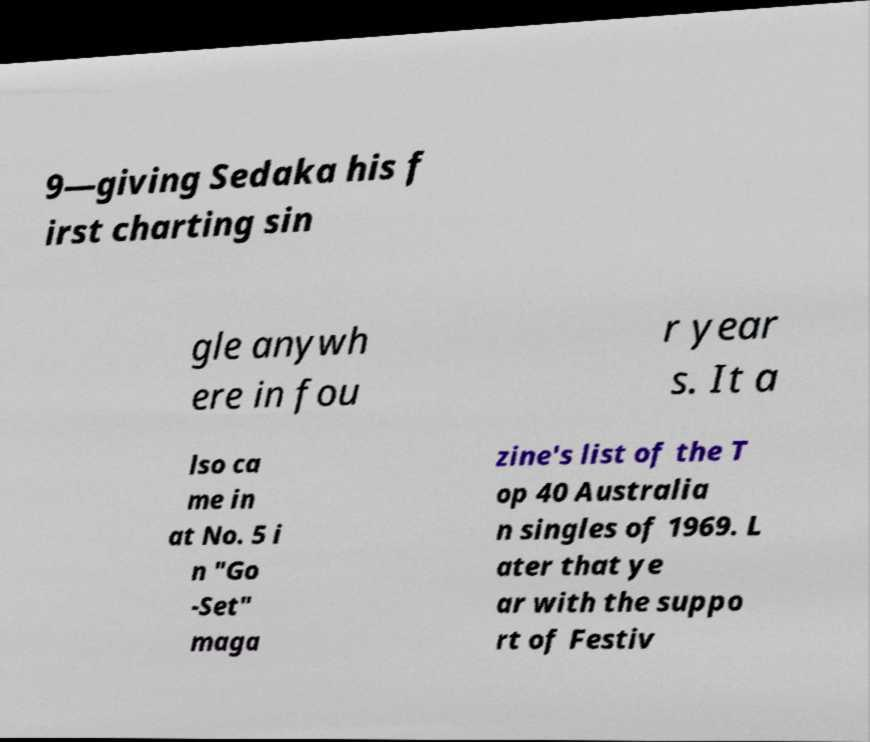I need the written content from this picture converted into text. Can you do that? 9—giving Sedaka his f irst charting sin gle anywh ere in fou r year s. It a lso ca me in at No. 5 i n "Go -Set" maga zine's list of the T op 40 Australia n singles of 1969. L ater that ye ar with the suppo rt of Festiv 